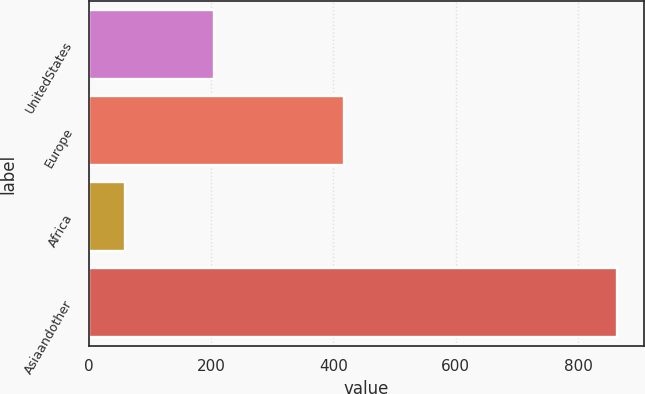Convert chart. <chart><loc_0><loc_0><loc_500><loc_500><bar_chart><fcel>UnitedStates<fcel>Europe<fcel>Africa<fcel>Asiaandother<nl><fcel>205<fcel>417<fcel>59<fcel>864<nl></chart> 